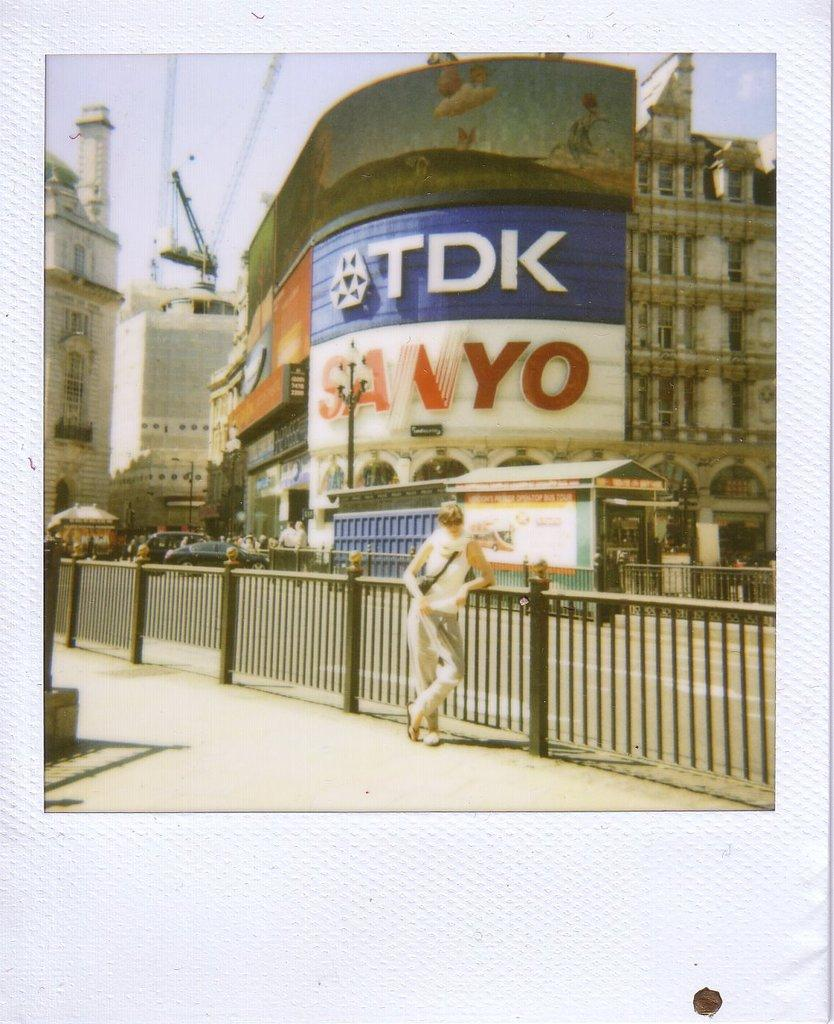What is the main subject of the image? There is a person standing in the image. What can be seen on the building in the image? There are names on the building. What is visible at the top of the image? The sky is visible at the top of the image. How does the person start to slip on the range in the image? There is no range or slipping person present in the image; it only features a person standing and a building with names on it. 